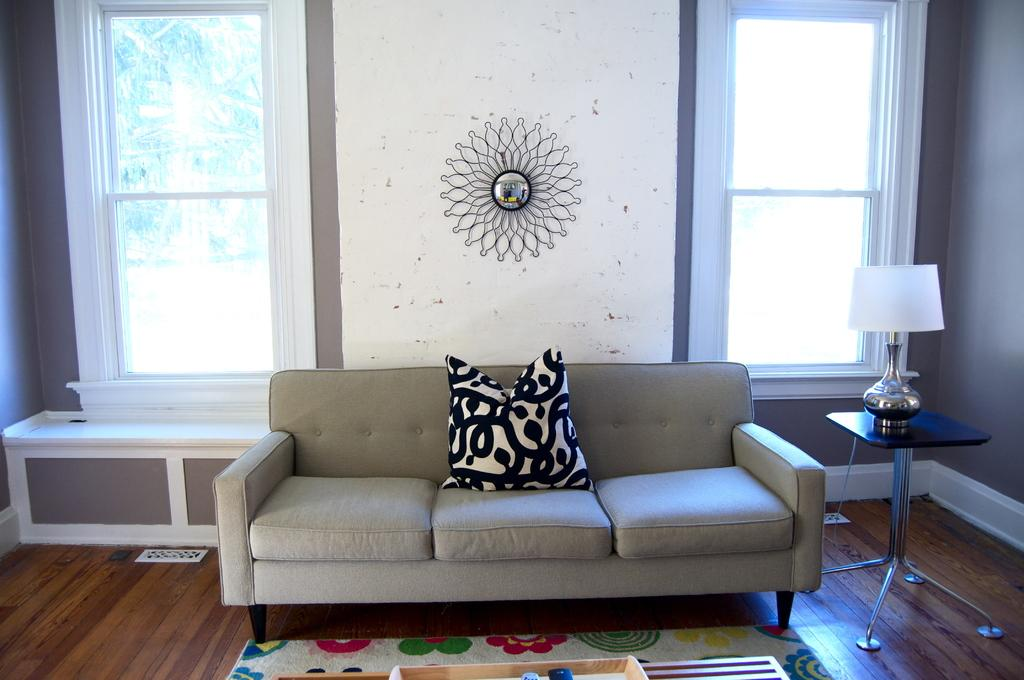What is placed on the sofa in the image? There is a pillow on the sofa. What is on the table in the image? There is a table lamp on the table. On which side of the image is the table lamp located? The table lamp is on the right side of the image. What can be seen in the background of the image? There are windows and a wall in the background of the image. What type of underwear is hanging on the wall in the image? There is no underwear present in the image; it features a pillow on the sofa, a table lamp on the table, and windows and a wall in the background. What color is the lace on the curtains in the image? There are no curtains or lace present in the image. 